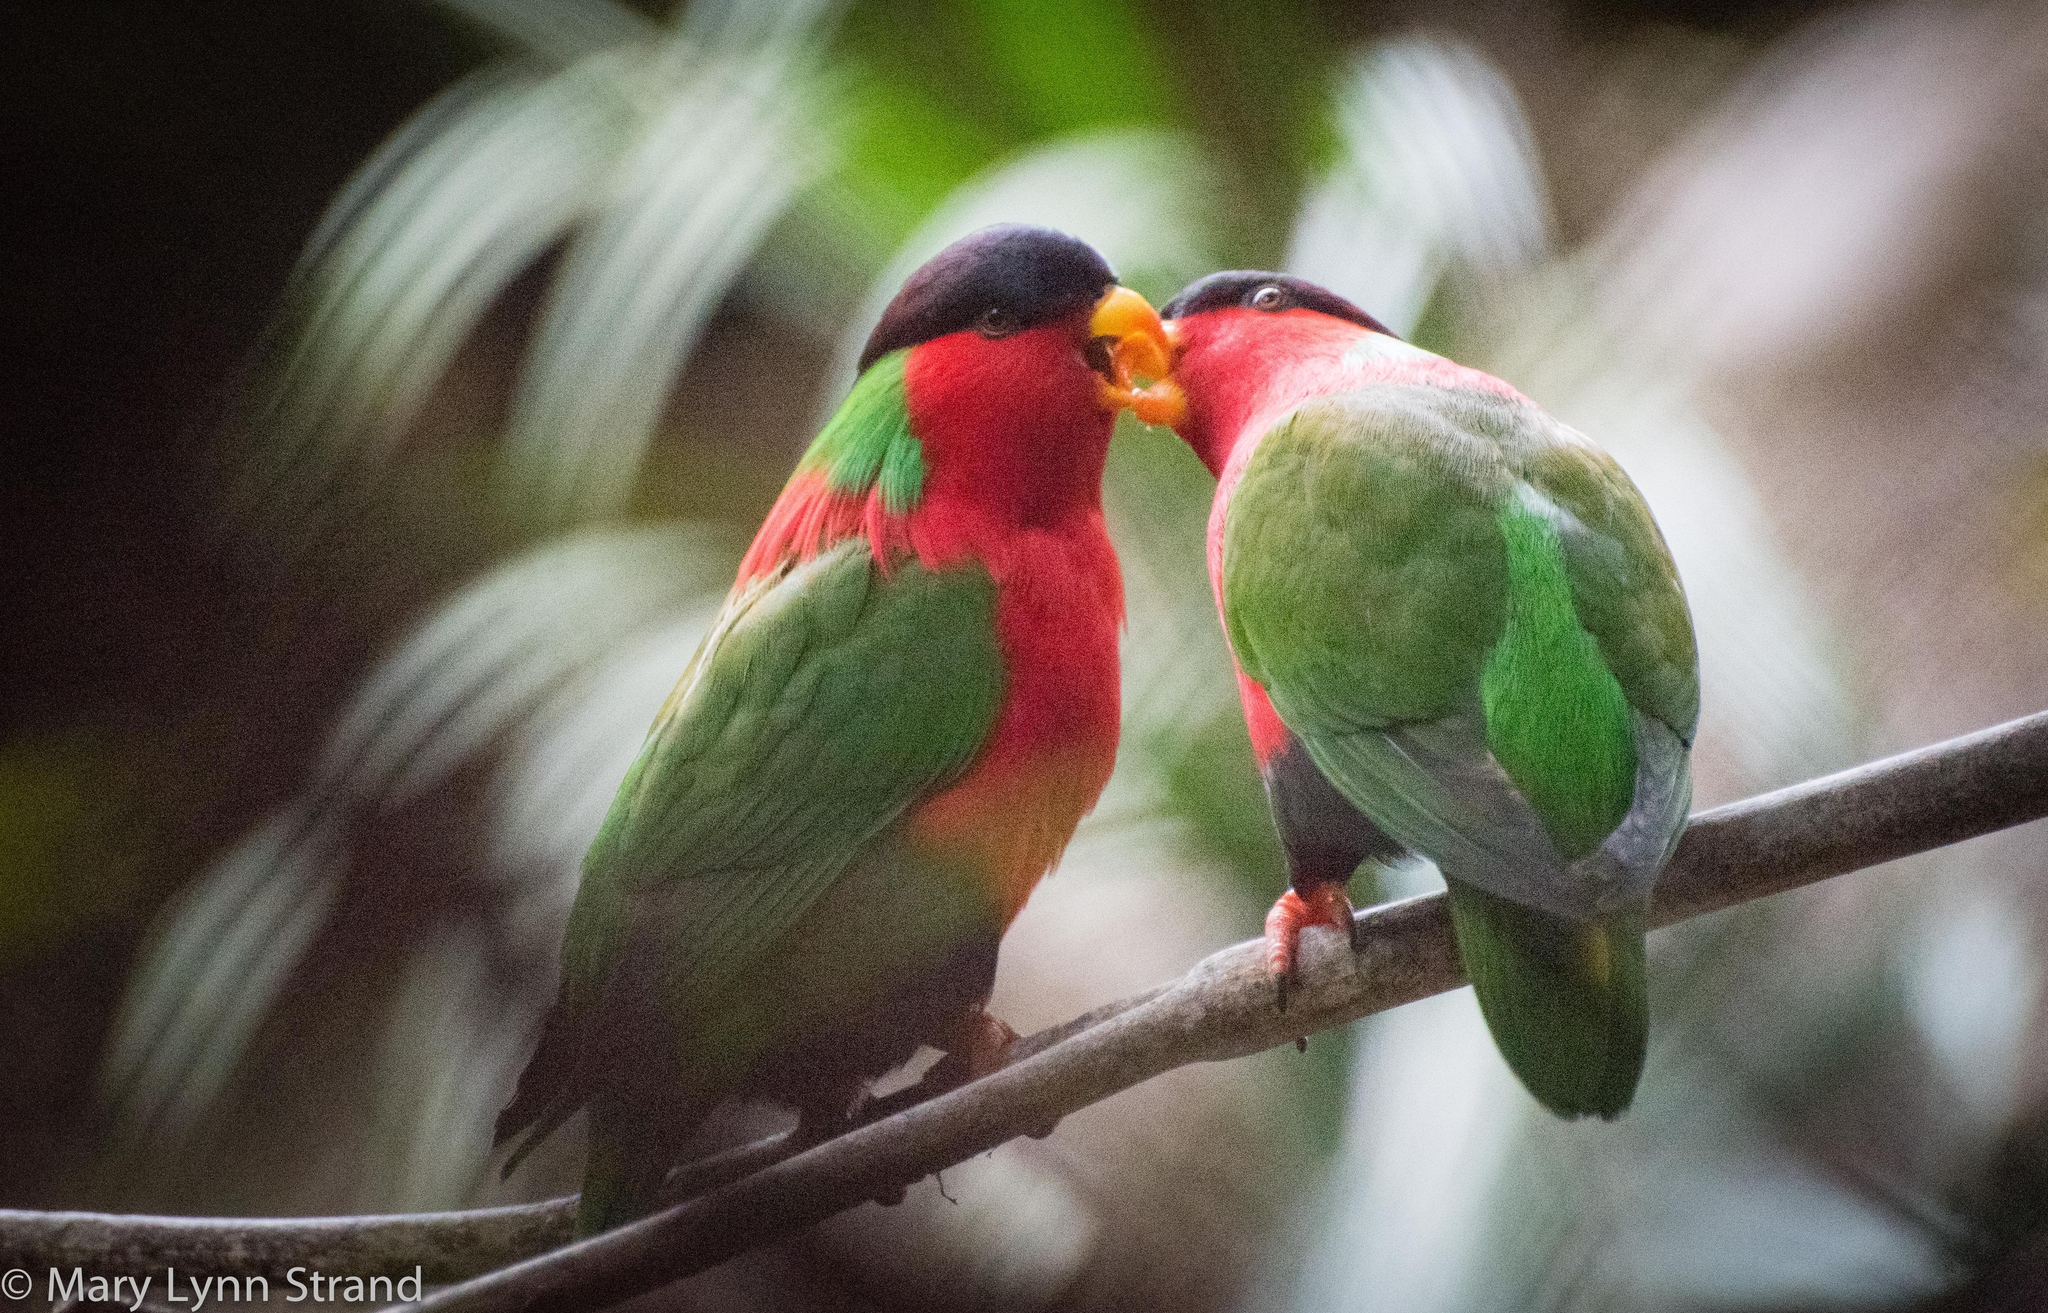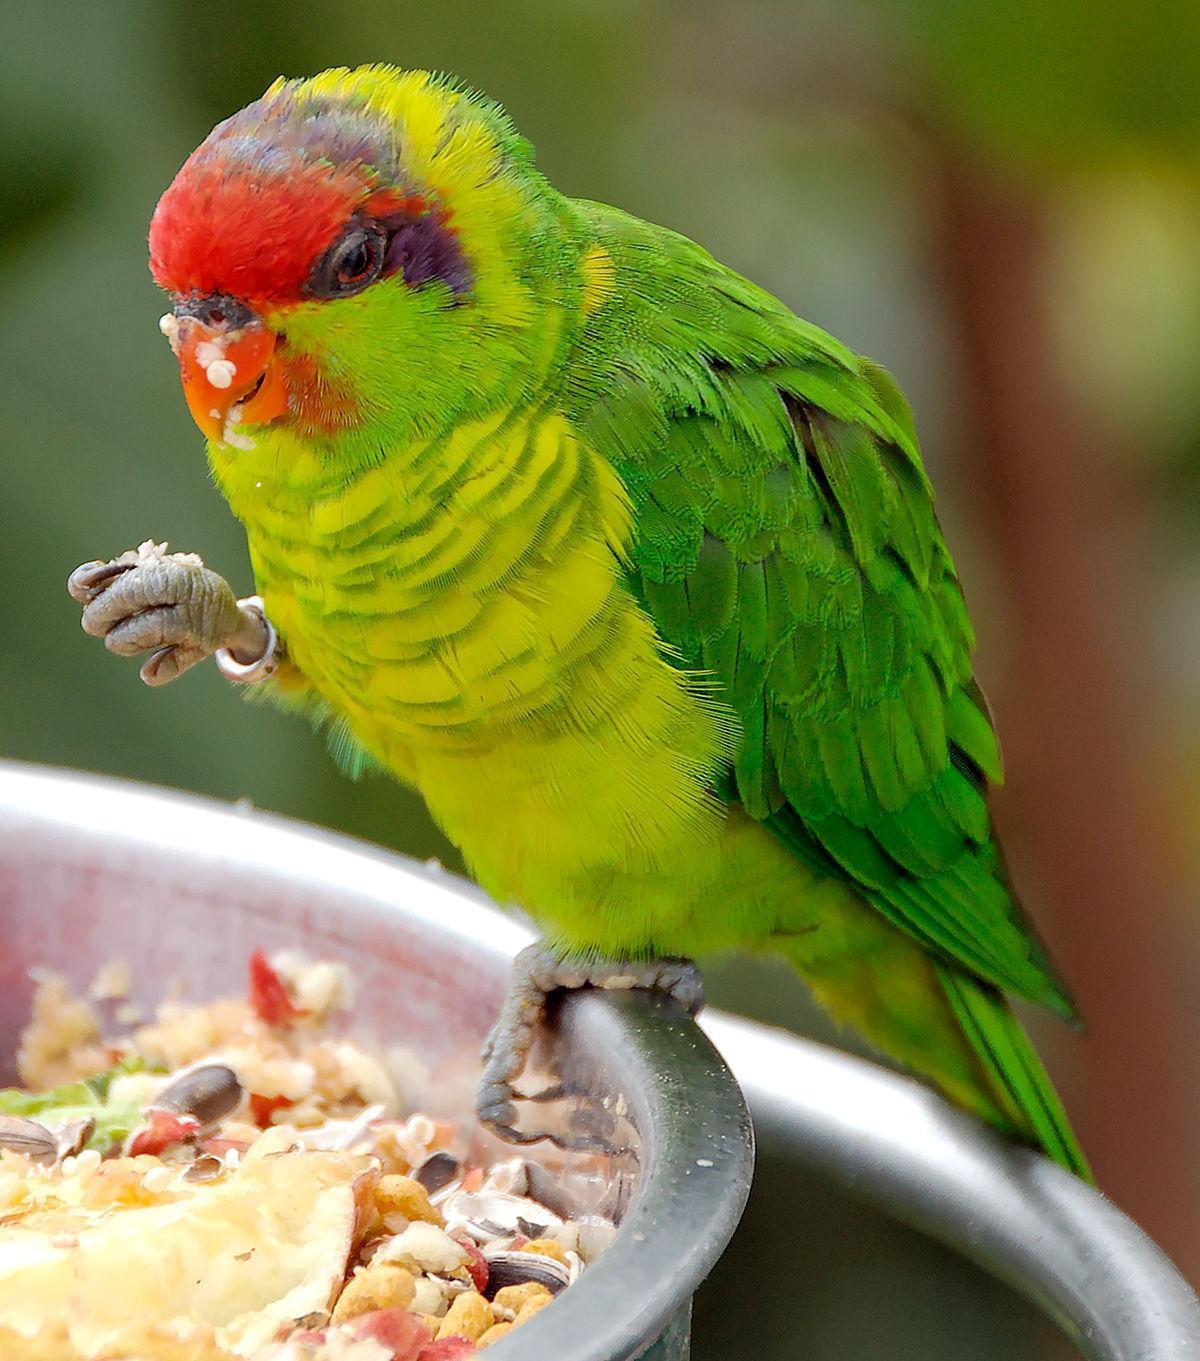The first image is the image on the left, the second image is the image on the right. Considering the images on both sides, is "A single bird is perched on the edge of a bowl and facing left in one image." valid? Answer yes or no. Yes. The first image is the image on the left, the second image is the image on the right. For the images displayed, is the sentence "There are 3 birds in the image pair" factually correct? Answer yes or no. Yes. 